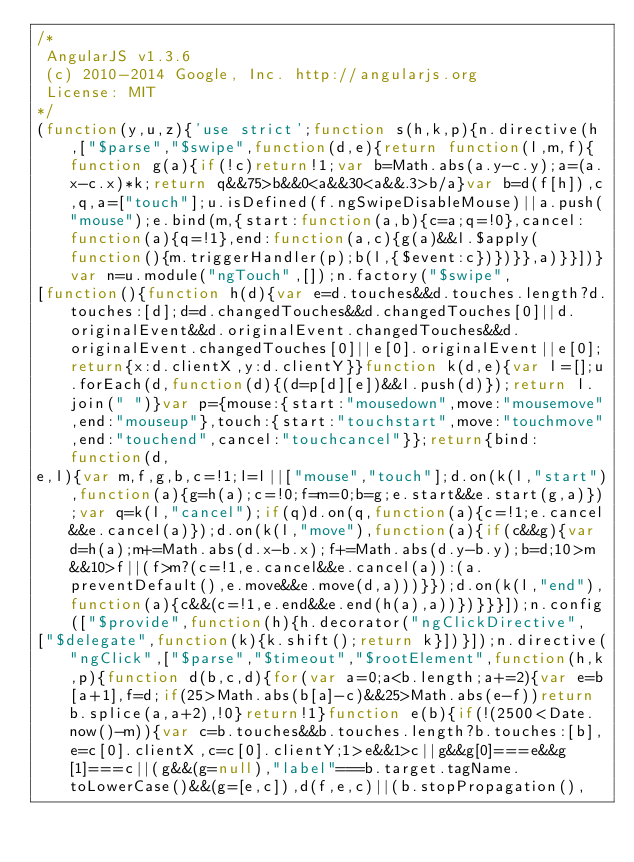<code> <loc_0><loc_0><loc_500><loc_500><_JavaScript_>/*
 AngularJS v1.3.6
 (c) 2010-2014 Google, Inc. http://angularjs.org
 License: MIT
*/
(function(y,u,z){'use strict';function s(h,k,p){n.directive(h,["$parse","$swipe",function(d,e){return function(l,m,f){function g(a){if(!c)return!1;var b=Math.abs(a.y-c.y);a=(a.x-c.x)*k;return q&&75>b&&0<a&&30<a&&.3>b/a}var b=d(f[h]),c,q,a=["touch"];u.isDefined(f.ngSwipeDisableMouse)||a.push("mouse");e.bind(m,{start:function(a,b){c=a;q=!0},cancel:function(a){q=!1},end:function(a,c){g(a)&&l.$apply(function(){m.triggerHandler(p);b(l,{$event:c})})}},a)}}])}var n=u.module("ngTouch",[]);n.factory("$swipe",
[function(){function h(d){var e=d.touches&&d.touches.length?d.touches:[d];d=d.changedTouches&&d.changedTouches[0]||d.originalEvent&&d.originalEvent.changedTouches&&d.originalEvent.changedTouches[0]||e[0].originalEvent||e[0];return{x:d.clientX,y:d.clientY}}function k(d,e){var l=[];u.forEach(d,function(d){(d=p[d][e])&&l.push(d)});return l.join(" ")}var p={mouse:{start:"mousedown",move:"mousemove",end:"mouseup"},touch:{start:"touchstart",move:"touchmove",end:"touchend",cancel:"touchcancel"}};return{bind:function(d,
e,l){var m,f,g,b,c=!1;l=l||["mouse","touch"];d.on(k(l,"start"),function(a){g=h(a);c=!0;f=m=0;b=g;e.start&&e.start(g,a)});var q=k(l,"cancel");if(q)d.on(q,function(a){c=!1;e.cancel&&e.cancel(a)});d.on(k(l,"move"),function(a){if(c&&g){var d=h(a);m+=Math.abs(d.x-b.x);f+=Math.abs(d.y-b.y);b=d;10>m&&10>f||(f>m?(c=!1,e.cancel&&e.cancel(a)):(a.preventDefault(),e.move&&e.move(d,a)))}});d.on(k(l,"end"),function(a){c&&(c=!1,e.end&&e.end(h(a),a))})}}}]);n.config(["$provide",function(h){h.decorator("ngClickDirective",
["$delegate",function(k){k.shift();return k}])}]);n.directive("ngClick",["$parse","$timeout","$rootElement",function(h,k,p){function d(b,c,d){for(var a=0;a<b.length;a+=2){var e=b[a+1],f=d;if(25>Math.abs(b[a]-c)&&25>Math.abs(e-f))return b.splice(a,a+2),!0}return!1}function e(b){if(!(2500<Date.now()-m)){var c=b.touches&&b.touches.length?b.touches:[b],e=c[0].clientX,c=c[0].clientY;1>e&&1>c||g&&g[0]===e&&g[1]===c||(g&&(g=null),"label"===b.target.tagName.toLowerCase()&&(g=[e,c]),d(f,e,c)||(b.stopPropagation(),</code> 